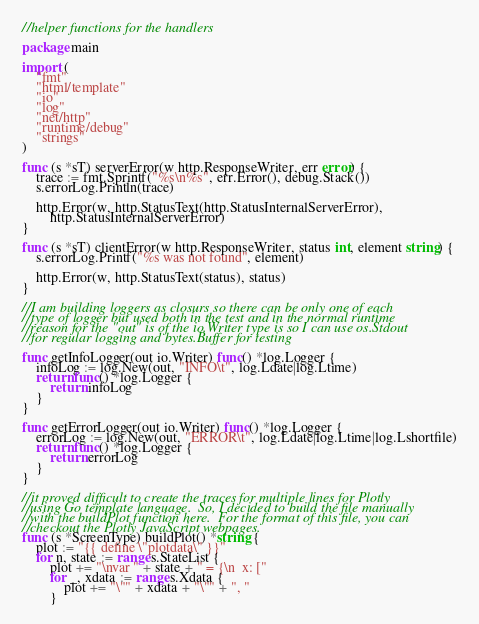Convert code to text. <code><loc_0><loc_0><loc_500><loc_500><_Go_>//helper functions for the handlers

package main

import (
	"fmt"
	"html/template"
	"io"
	"log"
	"net/http"
	"runtime/debug"
	"strings"
)

func (s *sT) serverError(w http.ResponseWriter, err error) {
	trace := fmt.Sprintf("%s\n%s", err.Error(), debug.Stack())
	s.errorLog.Println(trace)

	http.Error(w, http.StatusText(http.StatusInternalServerError),
		http.StatusInternalServerError)
}

func (s *sT) clientError(w http.ResponseWriter, status int, element string) {
	s.errorLog.Printf("%s was not found", element)

	http.Error(w, http.StatusText(status), status)
}

//I am building loggers as closurs so there can be only one of each
//type of logger but used both in the test and in the normal runtime
//reason for the "out" is of the io.Writer type is so I can use os.Stdout
//for regular logging and bytes.Buffer for testing

func getInfoLogger(out io.Writer) func() *log.Logger {
	infoLog := log.New(out, "INFO\t", log.Ldate|log.Ltime)
	return func() *log.Logger {
		return infoLog
	}
}

func getErrorLogger(out io.Writer) func() *log.Logger {
	errorLog := log.New(out, "ERROR\t", log.Ldate|log.Ltime|log.Lshortfile)
	return func() *log.Logger {
		return errorLog
	}
}

//it proved difficult to create the traces for multiple lines for Plotly
//using Go template language.  So, I decided to build the file manually
//with the buildPlot function here.  For the format of this file, you can
//checkout the Plotly JavaScript webpages.
func (s *ScreenType) buildPlot() *string {
	plot := "{{ define \"plotdata\" }}"
	for n, state := range s.StateList {
		plot += "\nvar " + state + " = {\n  x: ["
		for _, xdata := range s.Xdata {
			plot += "\"" + xdata + "\"" + ", "
		}</code> 